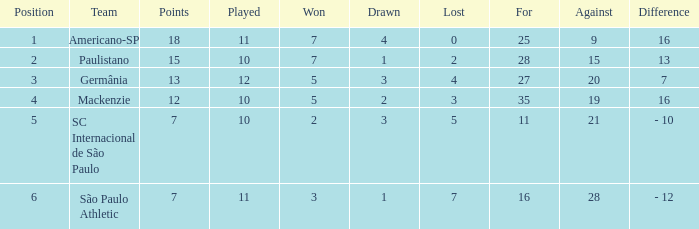Name the least for when played is 12 27.0. 